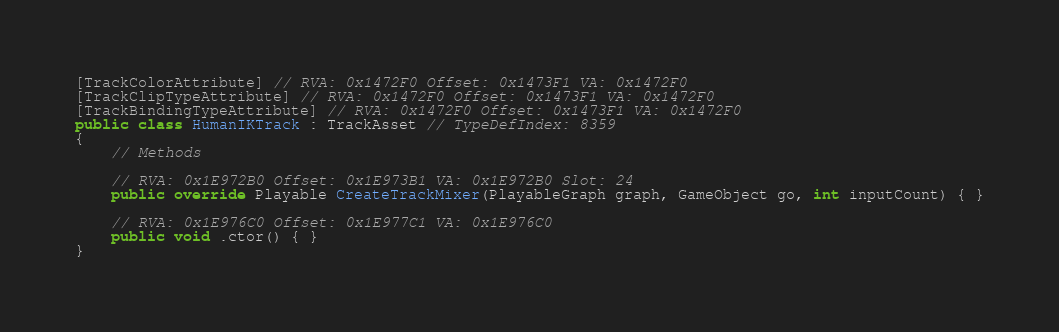Convert code to text. <code><loc_0><loc_0><loc_500><loc_500><_C#_>[TrackColorAttribute] // RVA: 0x1472F0 Offset: 0x1473F1 VA: 0x1472F0
[TrackClipTypeAttribute] // RVA: 0x1472F0 Offset: 0x1473F1 VA: 0x1472F0
[TrackBindingTypeAttribute] // RVA: 0x1472F0 Offset: 0x1473F1 VA: 0x1472F0
public class HumanIKTrack : TrackAsset // TypeDefIndex: 8359
{
	// Methods

	// RVA: 0x1E972B0 Offset: 0x1E973B1 VA: 0x1E972B0 Slot: 24
	public override Playable CreateTrackMixer(PlayableGraph graph, GameObject go, int inputCount) { }

	// RVA: 0x1E976C0 Offset: 0x1E977C1 VA: 0x1E976C0
	public void .ctor() { }
}

</code> 